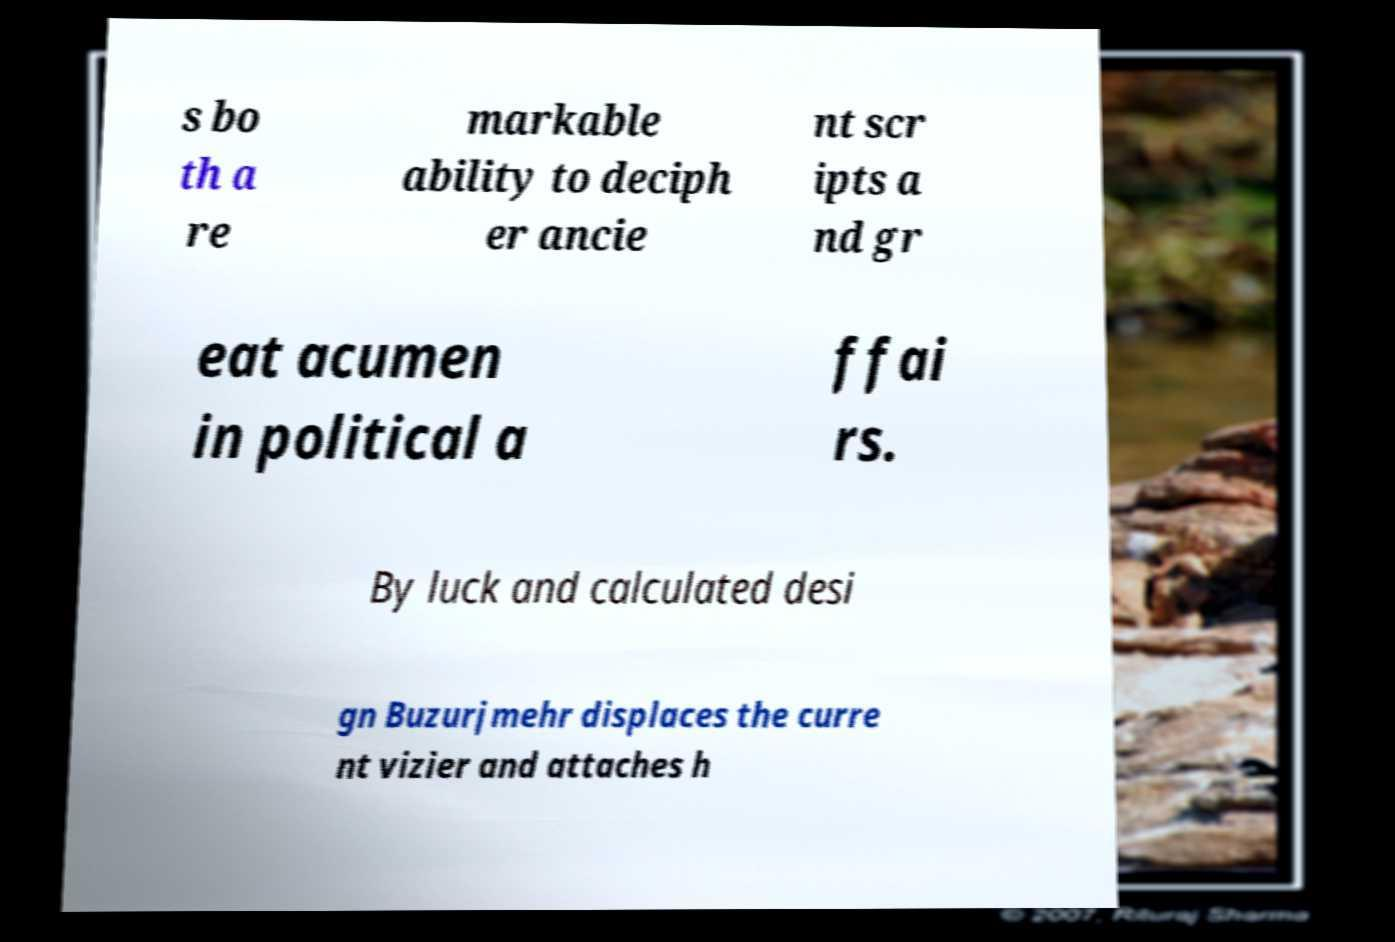Can you read and provide the text displayed in the image?This photo seems to have some interesting text. Can you extract and type it out for me? s bo th a re markable ability to deciph er ancie nt scr ipts a nd gr eat acumen in political a ffai rs. By luck and calculated desi gn Buzurjmehr displaces the curre nt vizier and attaches h 